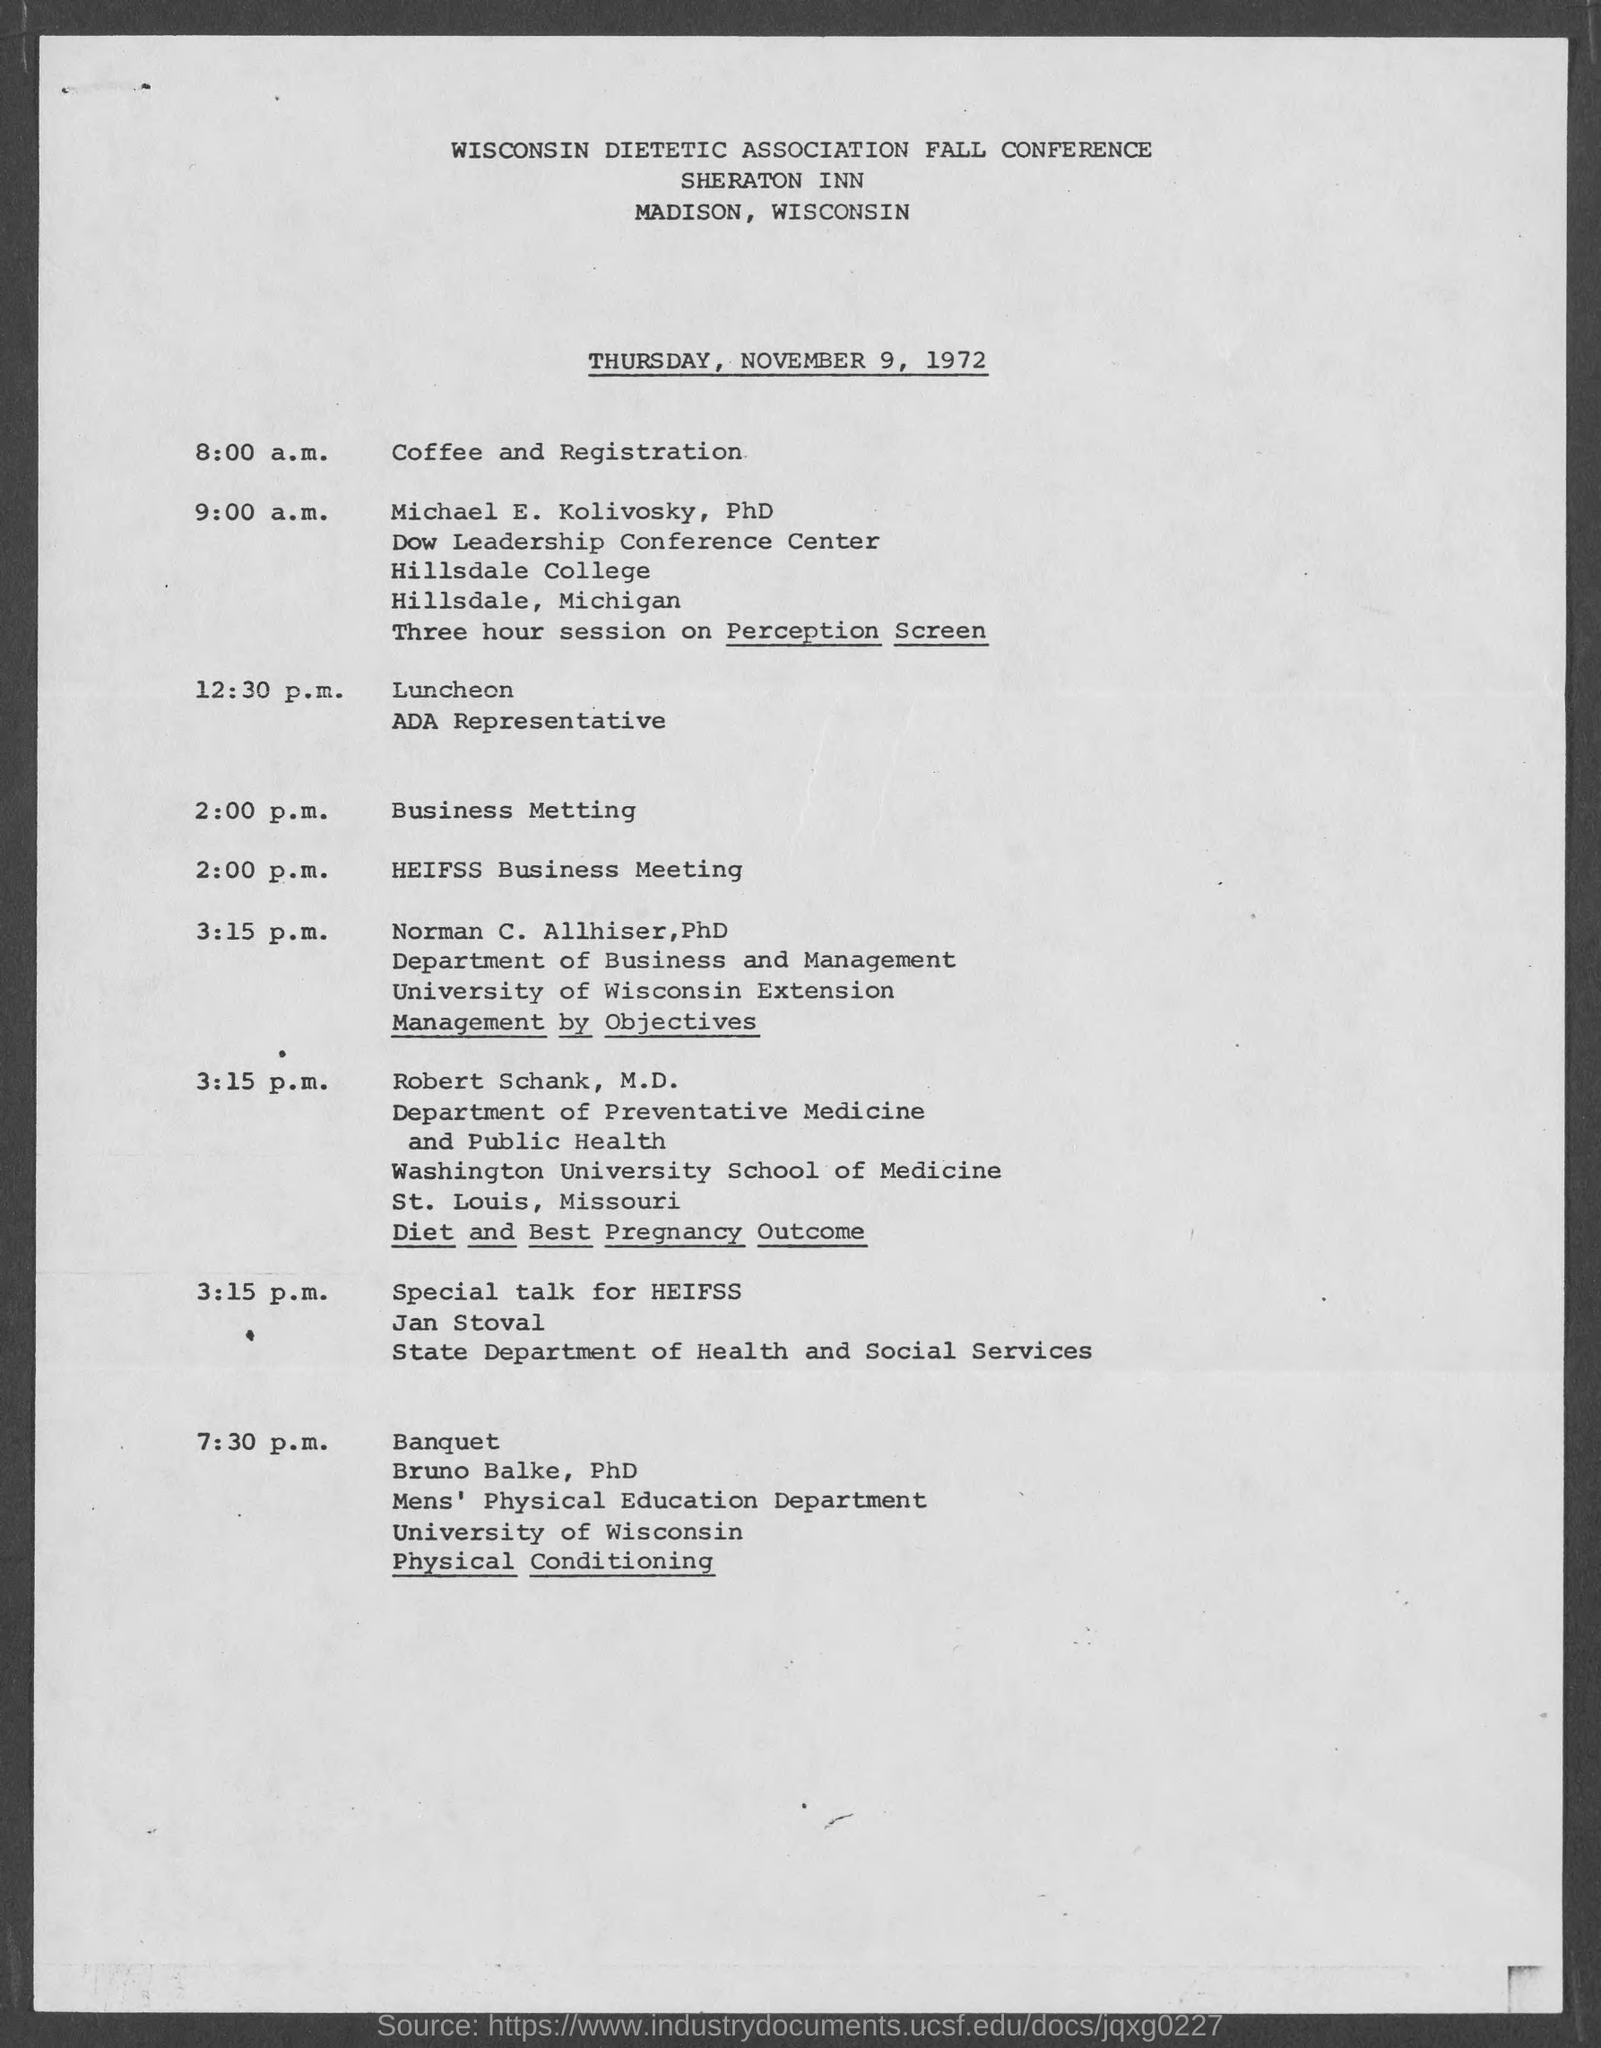Identify some key points in this picture. The conference will take place on Thursday, November 9, 1972. 